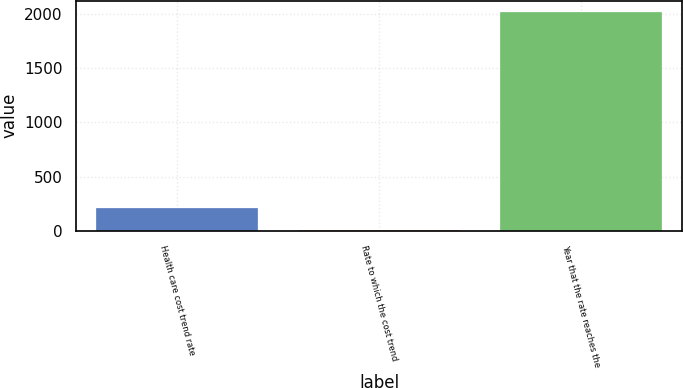Convert chart. <chart><loc_0><loc_0><loc_500><loc_500><bar_chart><fcel>Health care cost trend rate<fcel>Rate to which the cost trend<fcel>Year that the rate reaches the<nl><fcel>206.6<fcel>5<fcel>2021<nl></chart> 